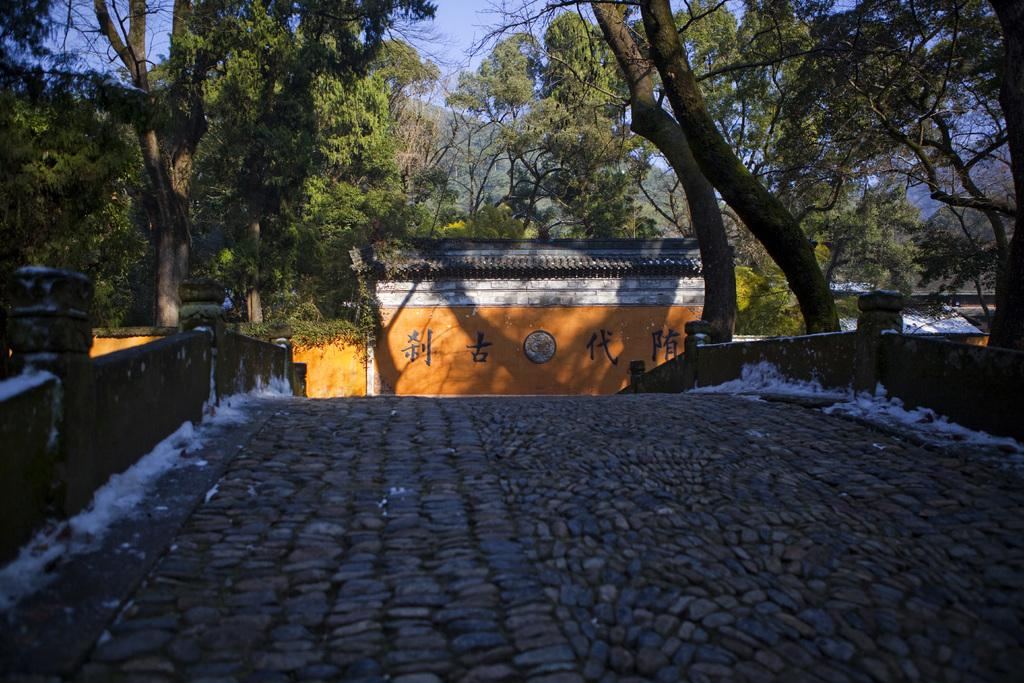What is located in the front of the image? There are walls and a rock surface in the front of the image. What can be seen in the background of the image? There are trees, the sky, a board, and buildings in the background of the image. How many different types of surfaces are visible in the image? There are two different types of surfaces visible: walls and a rock surface. What type of natural environment is visible in the image? The natural environment includes trees and the sky. Can you tell me how many toes are visible on the throne in the image? There is no throne present in the image, so it is not possible to determine the number of toes visible on it. 